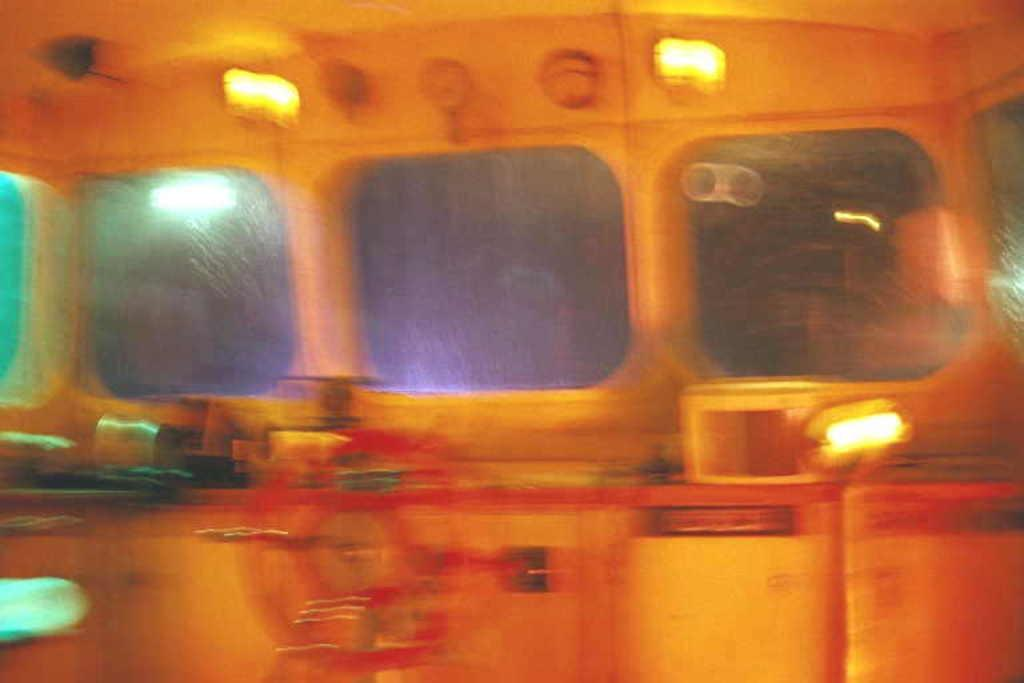What can be seen through the windows in the image? The details of what can be seen through the windows are not provided in the facts, so we cannot answer this question definitively. What is the wheel in the image used for? The purpose of the wheel in the image is not specified in the facts, so we cannot answer this question definitively. What book is the person reading in the image? There is no person or book present in the image, so we cannot answer this question definitively. 